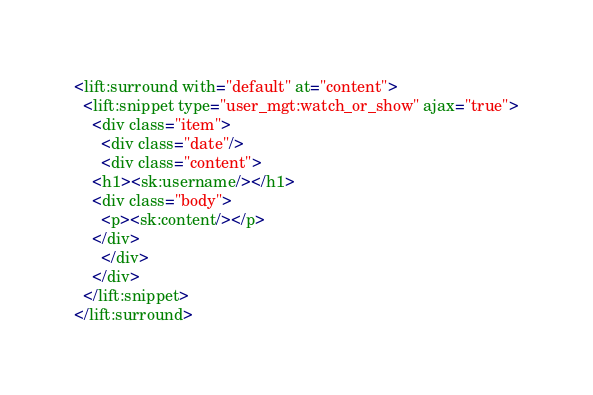Convert code to text. <code><loc_0><loc_0><loc_500><loc_500><_HTML_><lift:surround with="default" at="content">
  <lift:snippet type="user_mgt:watch_or_show" ajax="true">
    <div class="item">
      <div class="date"/>
      <div class="content">
	<h1><sk:username/></h1>
	<div class="body">
	  <p><sk:content/></p>
	</div>
      </div>
    </div>
  </lift:snippet>
</lift:surround>
</code> 